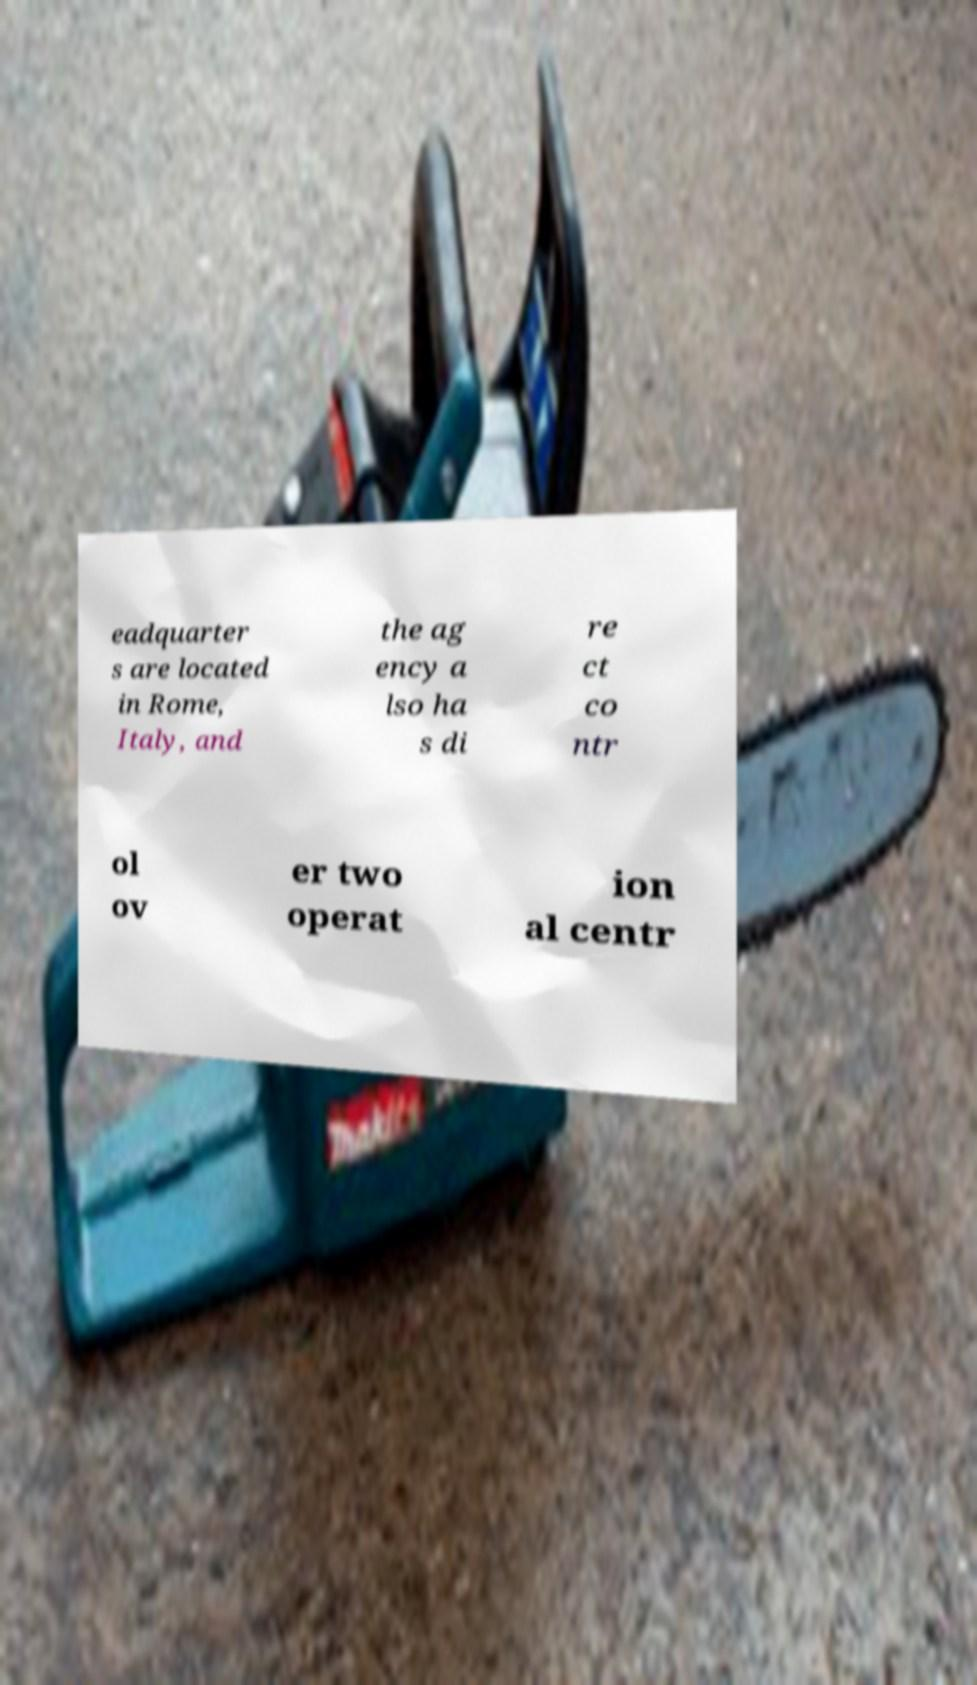Can you accurately transcribe the text from the provided image for me? eadquarter s are located in Rome, Italy, and the ag ency a lso ha s di re ct co ntr ol ov er two operat ion al centr 